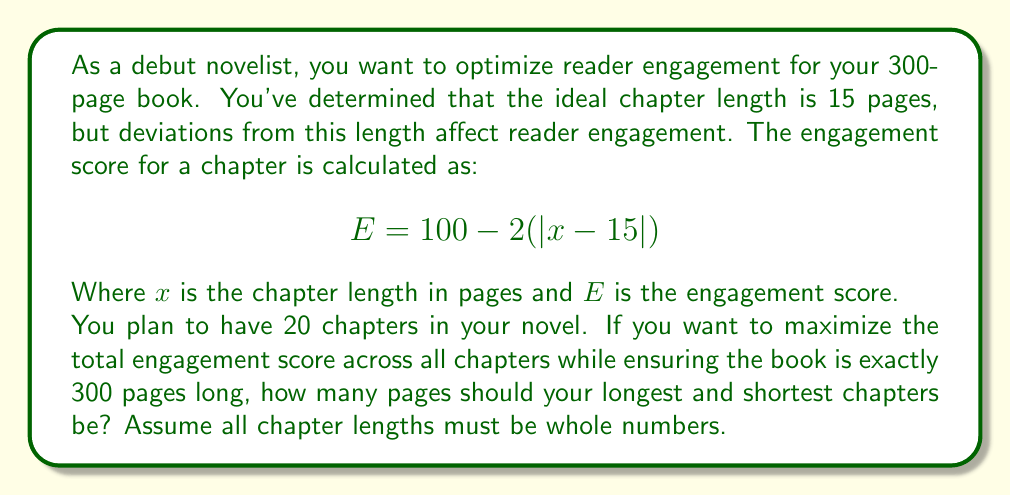Give your solution to this math problem. Let's approach this step-by-step:

1) First, we need to understand that we're trying to maximize the sum of engagement scores for all 20 chapters while keeping the total page count at 300.

2) The engagement score formula shows that any deviation from 15 pages reduces the score by 2 points per page of deviation.

3) To maximize the total score, we should keep as many chapters as possible at 15 pages, and distribute the remaining pages as evenly as possible among the other chapters.

4) With 20 chapters and 300 pages total, the average chapter length is 300/20 = 15 pages. This is fortunate, as it matches our ideal length.

5) However, since we need whole number page counts, we can't have all chapters at exactly 15 pages. We need to distribute the pages as evenly as possible.

6) The most even distribution would be to have some chapters at 14 pages, some at 15, and some at 16.

7) Let's say we have $a$ chapters at 14 pages, $b$ chapters at 15 pages, and $c$ chapters at 16 pages.

   We can set up two equations:
   $a + b + c = 20$ (total chapters)
   $14a + 15b + 16c = 300$ (total pages)

8) Solving these equations, we find that $a = 5$, $b = 10$, and $c = 5$.

9) Therefore, the shortest chapters are 14 pages and the longest are 16 pages.
Answer: The shortest chapters should be 14 pages long and the longest chapters should be 16 pages long. 